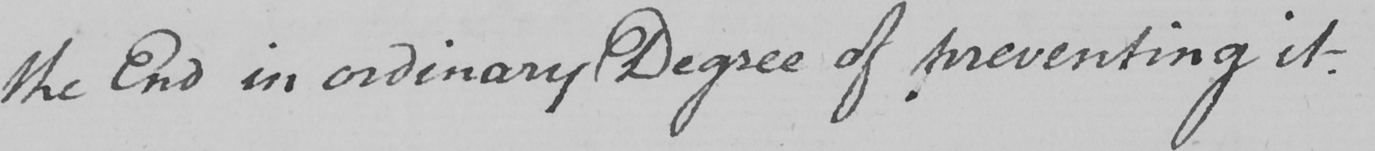Can you read and transcribe this handwriting? the End in ordinary Degree of preventing it . 